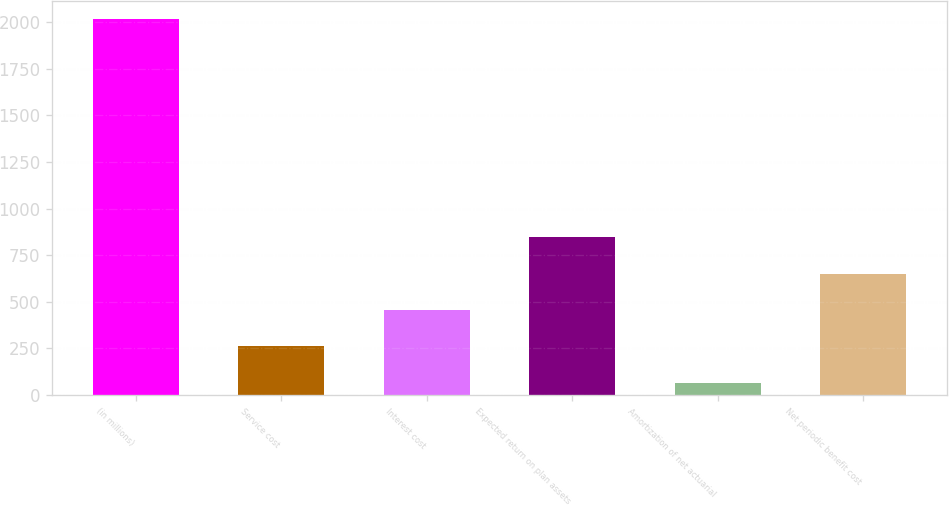Convert chart to OTSL. <chart><loc_0><loc_0><loc_500><loc_500><bar_chart><fcel>(in millions)<fcel>Service cost<fcel>Interest cost<fcel>Expected return on plan assets<fcel>Amortization of net actuarial<fcel>Net periodic benefit cost<nl><fcel>2015<fcel>260<fcel>455<fcel>845<fcel>65<fcel>650<nl></chart> 